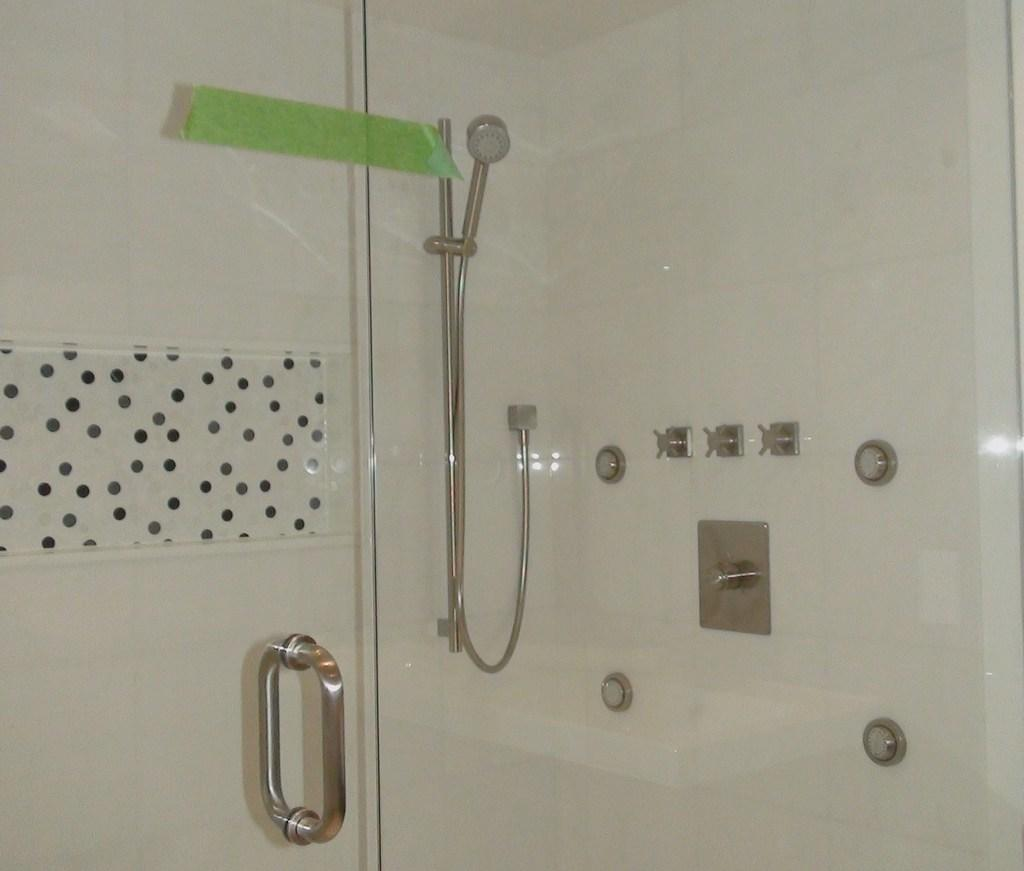What object is visible in the image that is typically used for drinking? There is a glass in the image. What feature can be seen on the door in the image? There is a door handle fixed to a door in the image. What type of fixture is present in the image for bathing? There is a shower in the image. What color is the wall visible in the background of the image? There is a white color wall in the background of the image. Can you see any fangs in the image? There are no fangs present in the image. Is the person in the image stuck in quicksand? There is no person visible in the image, and therefore no one can be stuck in quicksand. 